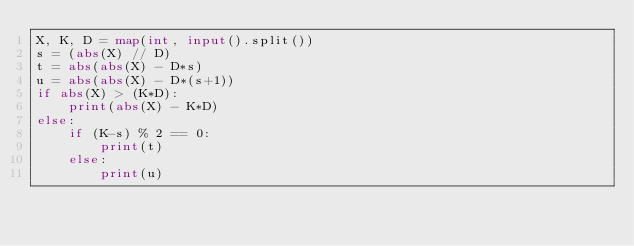Convert code to text. <code><loc_0><loc_0><loc_500><loc_500><_Python_>X, K, D = map(int, input().split())
s = (abs(X) // D)
t = abs(abs(X) - D*s)
u = abs(abs(X) - D*(s+1))
if abs(X) > (K*D):
    print(abs(X) - K*D)
else:
    if (K-s) % 2 == 0:
        print(t)
    else:
        print(u)</code> 